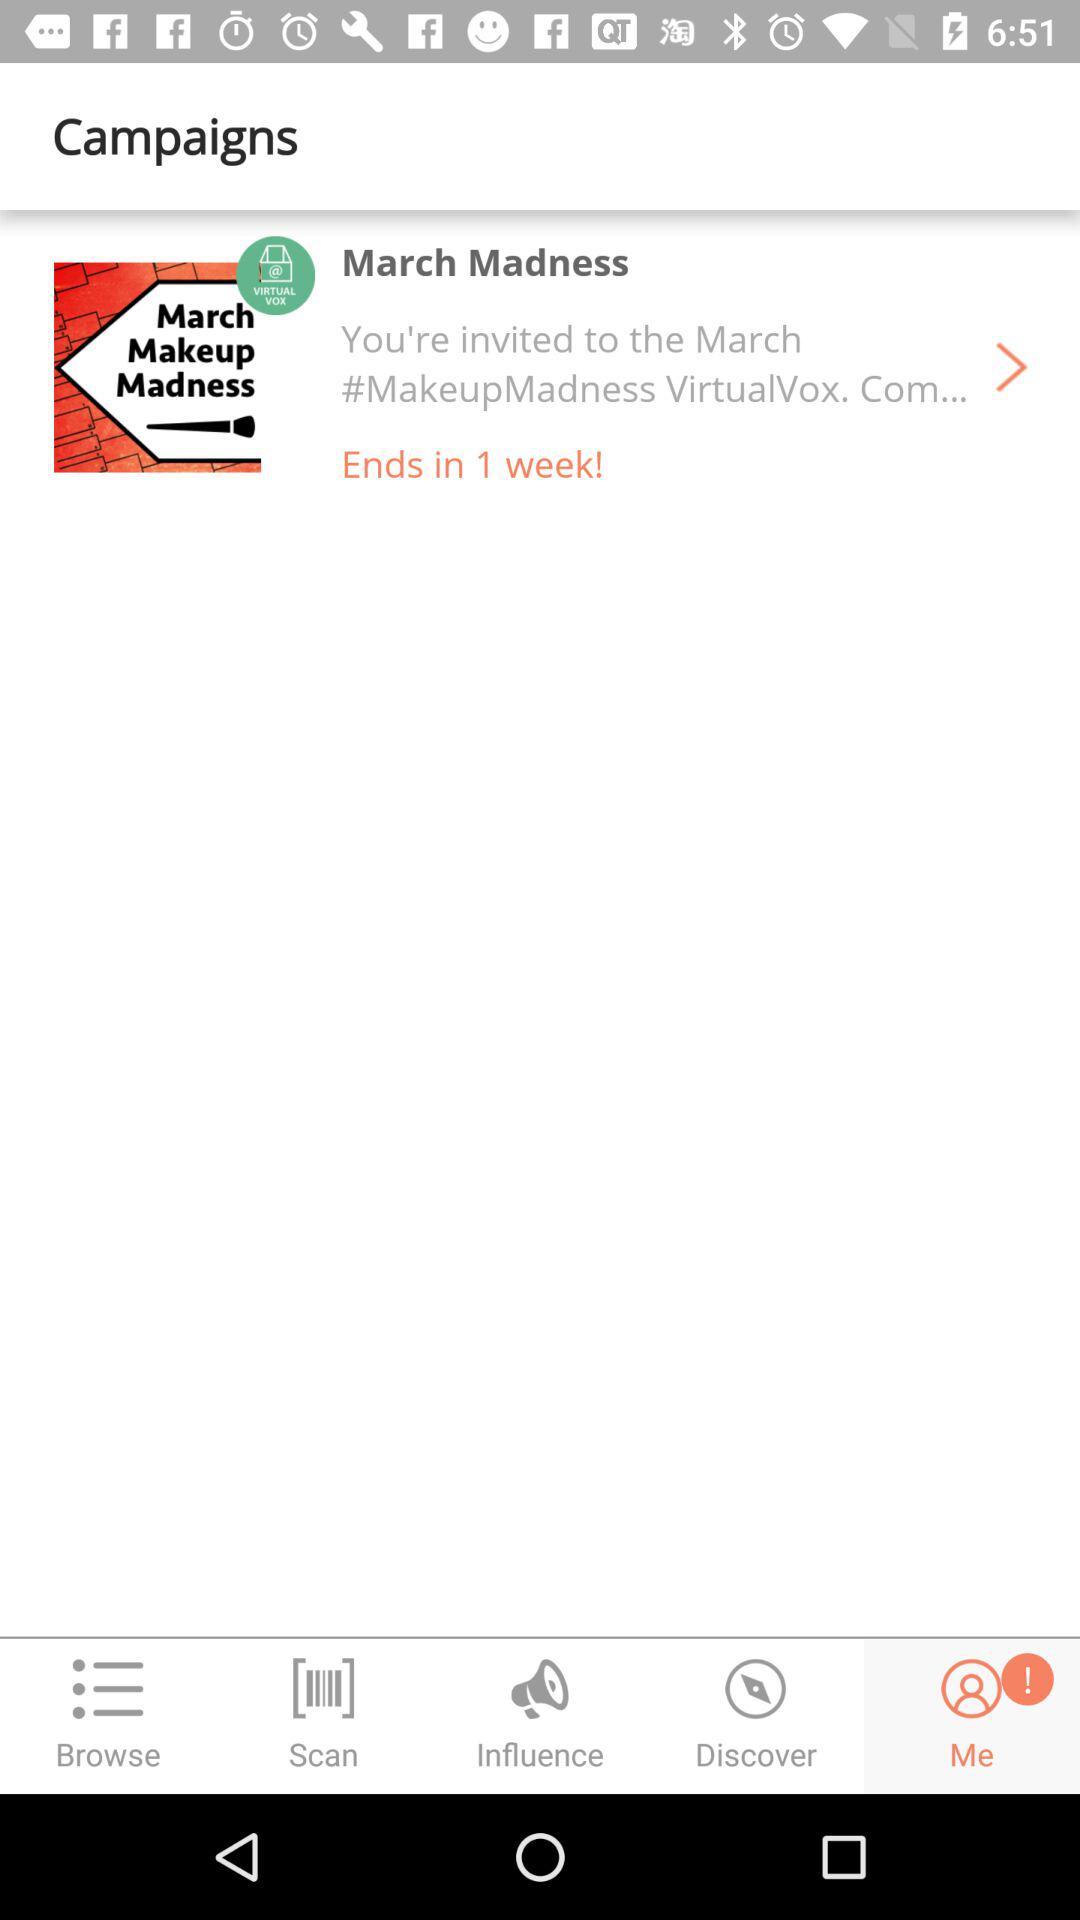What is the name of the campaign? The name of the campaign is "March Madness". 